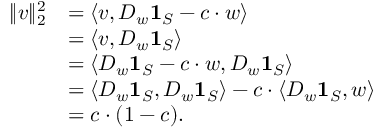<formula> <loc_0><loc_0><loc_500><loc_500>\begin{array} { r l } { \| v \| _ { 2 } ^ { 2 } } & { = \langle v , D _ { w } 1 _ { S } - c \cdot w \rangle } \\ & { = \langle v , D _ { w } 1 _ { S } \rangle } \\ & { = \langle D _ { w } 1 _ { S } - c \cdot w , D _ { w } 1 _ { S } \rangle } \\ & { = \langle D _ { w } 1 _ { S } , D _ { w } 1 _ { S } \rangle - c \cdot \langle D _ { w } 1 _ { S } , w \rangle } \\ & { = c \cdot ( 1 - c ) . } \end{array}</formula> 